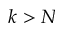Convert formula to latex. <formula><loc_0><loc_0><loc_500><loc_500>k > N</formula> 